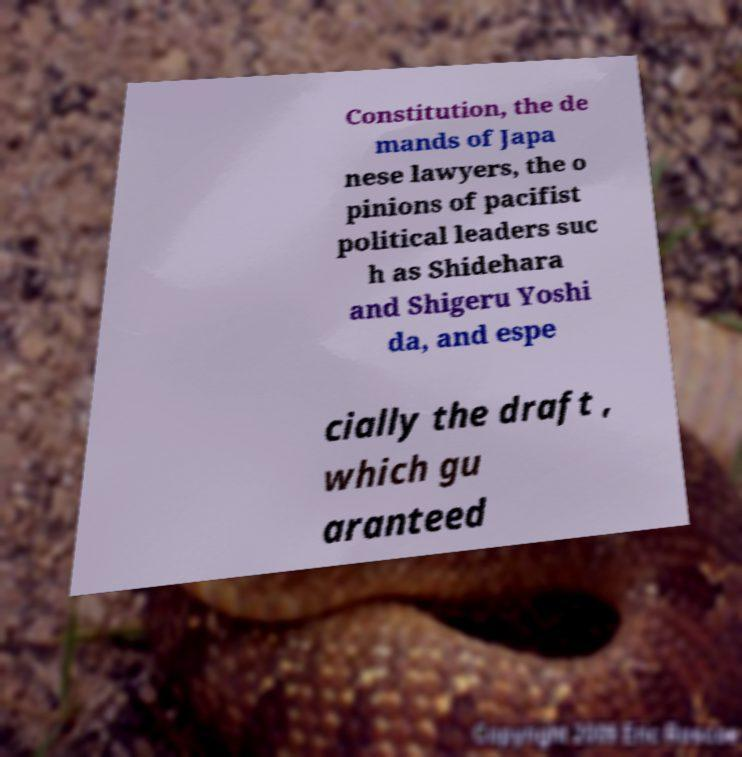Could you assist in decoding the text presented in this image and type it out clearly? Constitution, the de mands of Japa nese lawyers, the o pinions of pacifist political leaders suc h as Shidehara and Shigeru Yoshi da, and espe cially the draft , which gu aranteed 